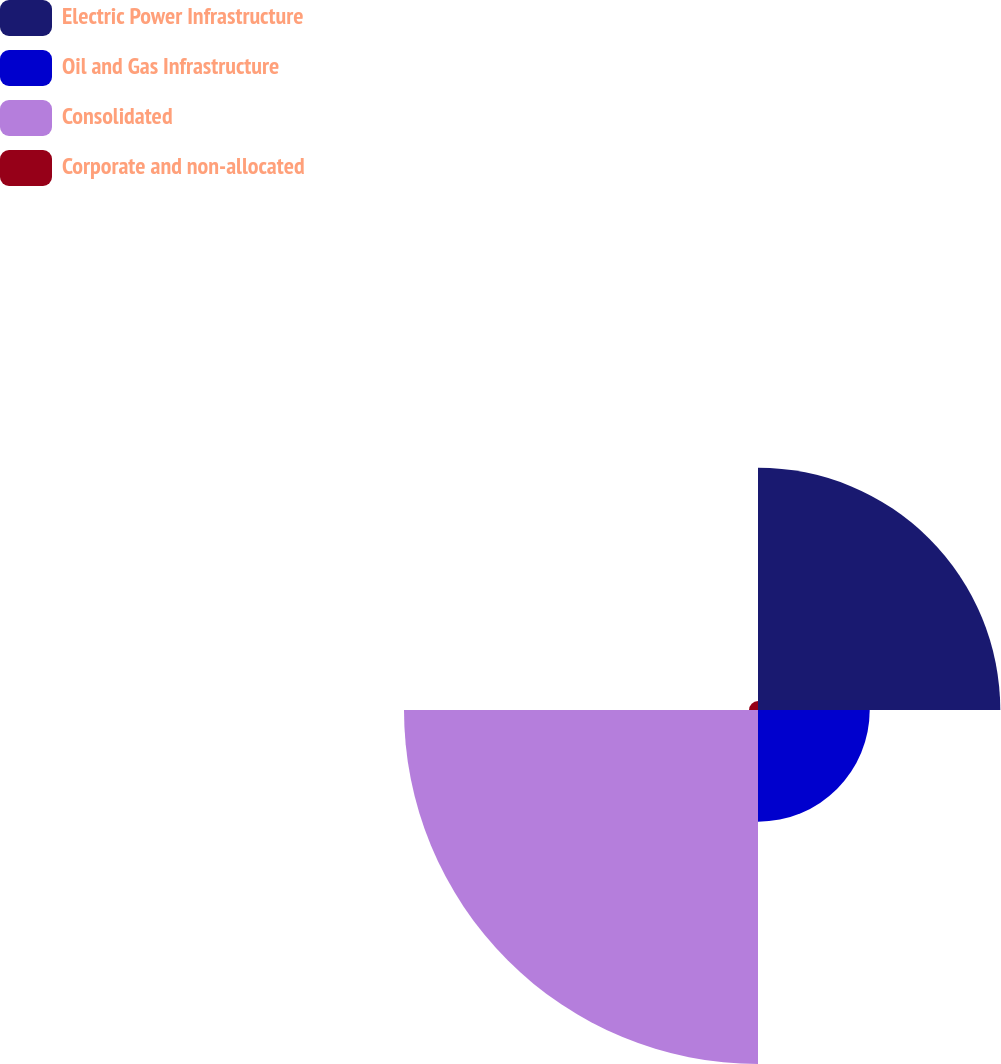Convert chart. <chart><loc_0><loc_0><loc_500><loc_500><pie_chart><fcel>Electric Power Infrastructure<fcel>Oil and Gas Infrastructure<fcel>Consolidated<fcel>Corporate and non-allocated<nl><fcel>33.79%<fcel>15.58%<fcel>49.37%<fcel>1.25%<nl></chart> 